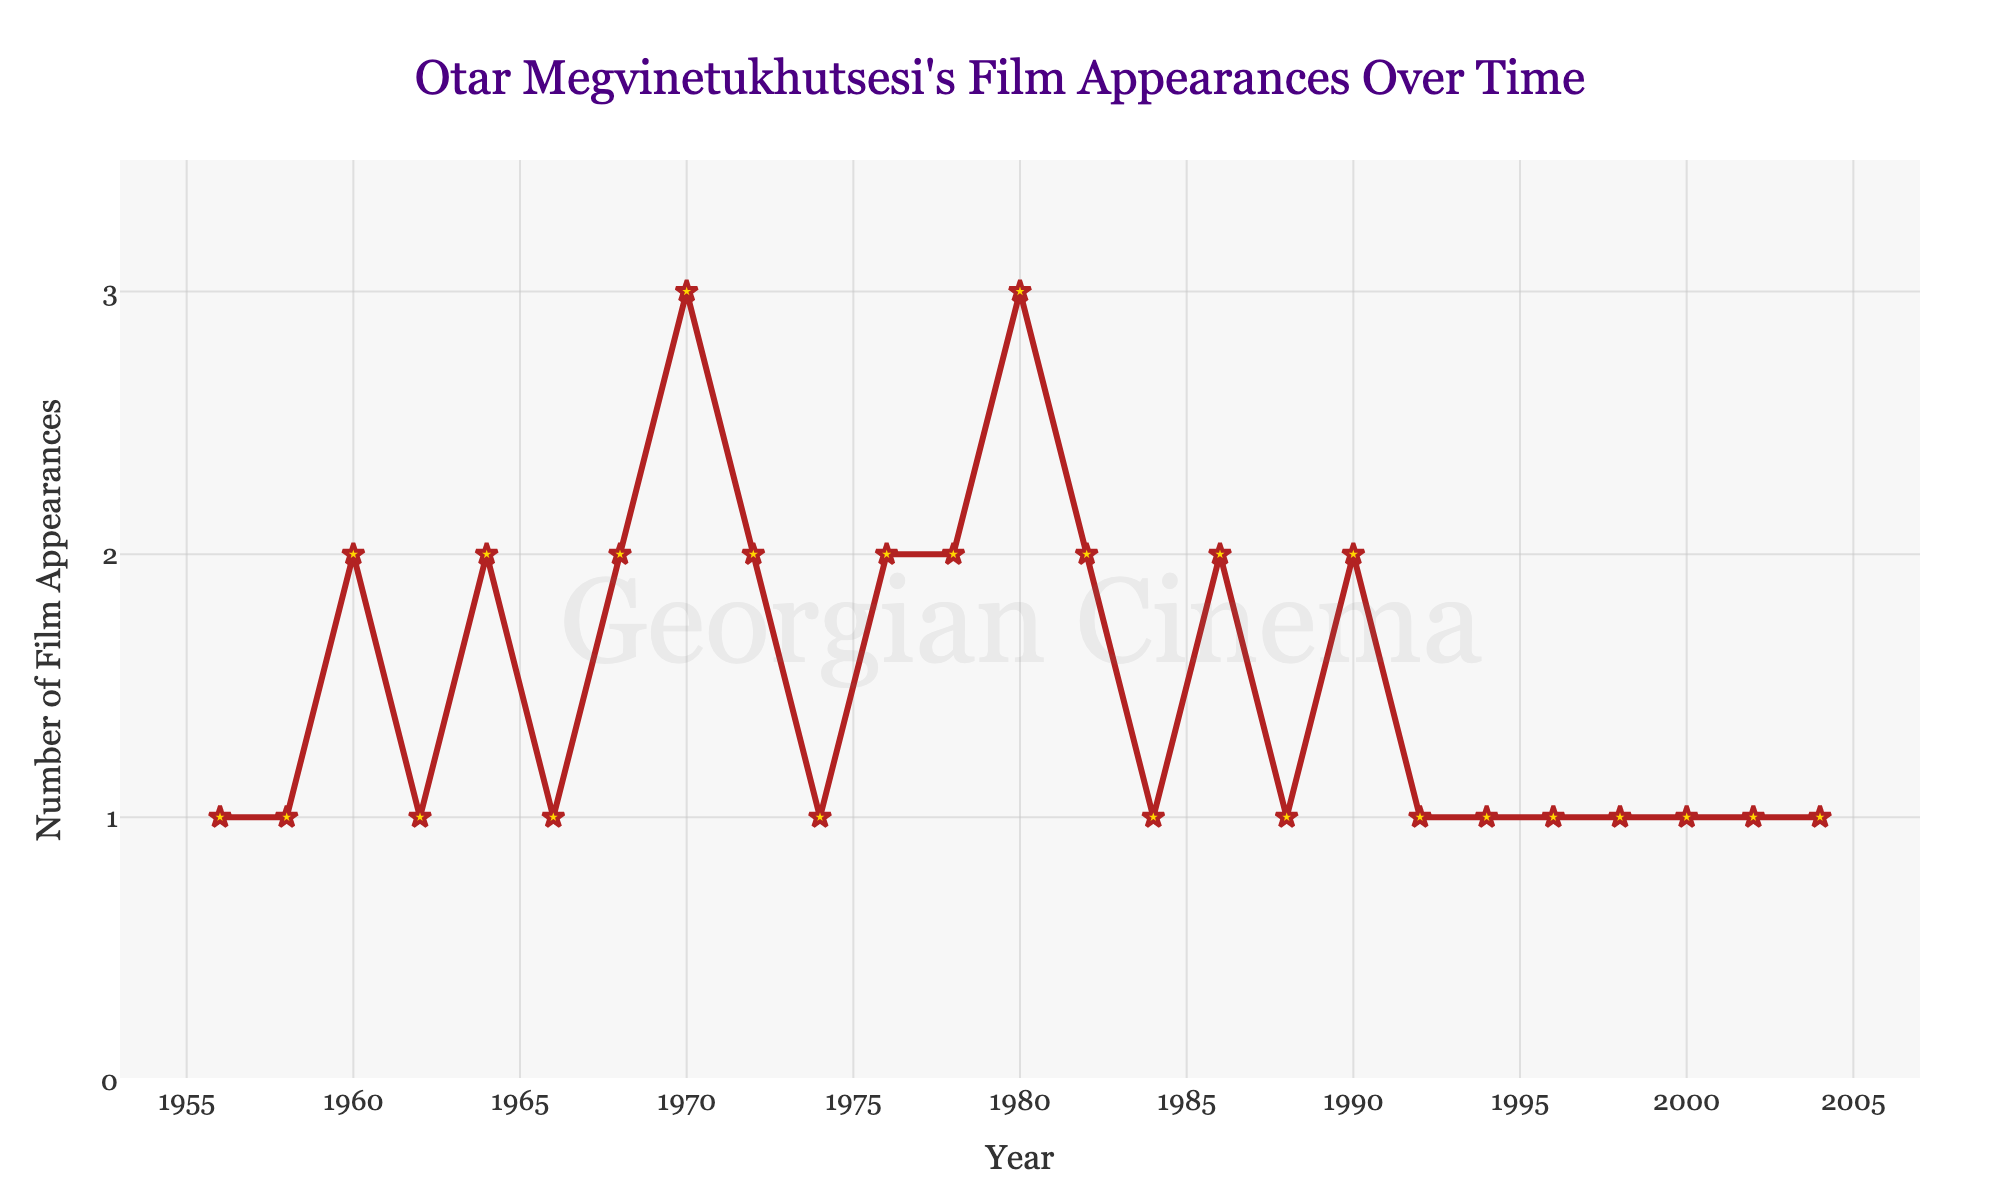What is the total number of films Otar Megvinetukhutsesi appeared in between 1960 and 1970? First, identify the film appearances for each year from 1960 to 1970: 1960 (2), 1962 (1), 1964 (2), 1966 (1), 1968 (2), and 1970 (3). Summing these values: 2 + 1 + 2 + 1 + 2 + 3 = 11
Answer: 11 In which year did Otar Megvinetukhutsesi have the highest number of film appearances, and how many appearances were there? By observing the y-axis values, the peak value is 3, which occurs in 1970 and 1980. So, the highest number of film appearances in a single year was 3 in the years 1970 and 1980
Answer: 1970 and 1980, 3 How many years had exactly 1 film appearance? By scanning through the y-axis values, count the years where the film appearances are 1: 1956, 1958, 1962, 1966, 1974, 1984, 1988, 1992, 1994, 1996, 1998, 2000, 2002, 2004. There are 14 such years
Answer: 14 Compare the number of film appearances between the years 1986 and 1988. What is the difference? The number of film appearances in 1986 is 2, and in 1988 it is 1. The difference is calculated as 2 - 1 = 1
Answer: 1 What is the average number of film appearances per year across the entire dataset? Sum all film appearances: 1 + 1 + 2 + 1 + 2 + 1 + 2 + 3 + 2 + 1 + 2 + 2 + 3 + 2 + 1 + 2 + 1 + 2 + 1 + 1 + 1 + 1 + 1 + 1 + 1 = 39. There are 25 years in the dataset. Average = 39 / 25 = 1.56
Answer: 1.56 Between 1980 and 1990, in which year did Otar Megvinetukhutsesi appear in the most films? Look at the data from 1980 to 1990: 1980 (3), 1982 (2), 1984 (1), 1986 (2), 1988 (1), 1990 (2). The highest value is 3 in 1980
Answer: 1980 Which decade had more film appearances, the 1960s or the 1980s? Sum film appearances in the 1960s: 2 (1960) + 1 (1962) + 2 (1964) + 1 (1966) + 2 (1968) = 8. Sum film appearances in the 1980s: 3 (1980) + 2 (1982) + 1 (1984) + 2 (1986) + 1 (1988) = 9. The 1980s had more: 9 > 8
Answer: 1980s How did the number of appearances in 1970 compare to those in 1982? The year 1970 had 3 appearances, and 1982 had 2 appearances. Comparing the two: 3 is greater than 2
Answer: 1970 had more What is the trend of film appearances after 1990? The film appearances after 1990 are as follows: 1992 (1), 1994 (1), 1996 (1), 1998 (1), 2000 (1), 2002 (1), 2004 (1). The trend shows that there are consistently 1 film appearance every two years
Answer: Consistently 1 appearance 